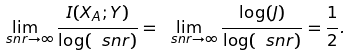<formula> <loc_0><loc_0><loc_500><loc_500>\lim _ { \ s n r \rightarrow \infty } \frac { I ( X _ { A } ; Y ) } { \log ( \ s n r ) } = \lim _ { \ s n r \rightarrow \infty } \frac { \log ( J ) } { \log ( \ s n r ) } = \frac { 1 } { 2 } .</formula> 